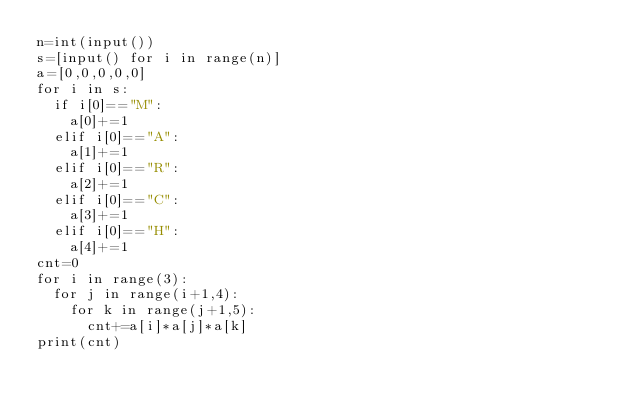<code> <loc_0><loc_0><loc_500><loc_500><_Python_>n=int(input())
s=[input() for i in range(n)]
a=[0,0,0,0,0]
for i in s:
  if i[0]=="M":
    a[0]+=1
  elif i[0]=="A":
    a[1]+=1
  elif i[0]=="R":
    a[2]+=1
  elif i[0]=="C":
    a[3]+=1
  elif i[0]=="H":
    a[4]+=1
cnt=0
for i in range(3):
  for j in range(i+1,4):
    for k in range(j+1,5):
      cnt+=a[i]*a[j]*a[k]
print(cnt)
</code> 